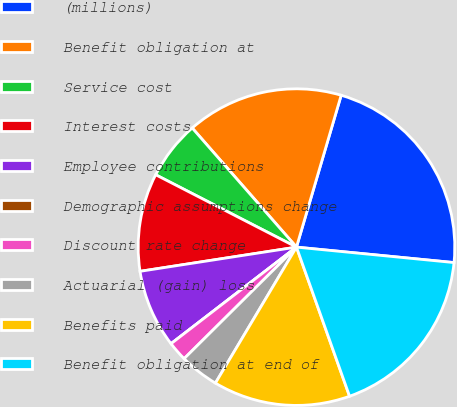<chart> <loc_0><loc_0><loc_500><loc_500><pie_chart><fcel>(millions)<fcel>Benefit obligation at<fcel>Service cost<fcel>Interest costs<fcel>Employee contributions<fcel>Demographic assumptions change<fcel>Discount rate change<fcel>Actuarial (gain) loss<fcel>Benefits paid<fcel>Benefit obligation at end of<nl><fcel>22.0%<fcel>16.0%<fcel>6.0%<fcel>10.0%<fcel>8.0%<fcel>0.0%<fcel>2.0%<fcel>4.0%<fcel>14.0%<fcel>18.0%<nl></chart> 